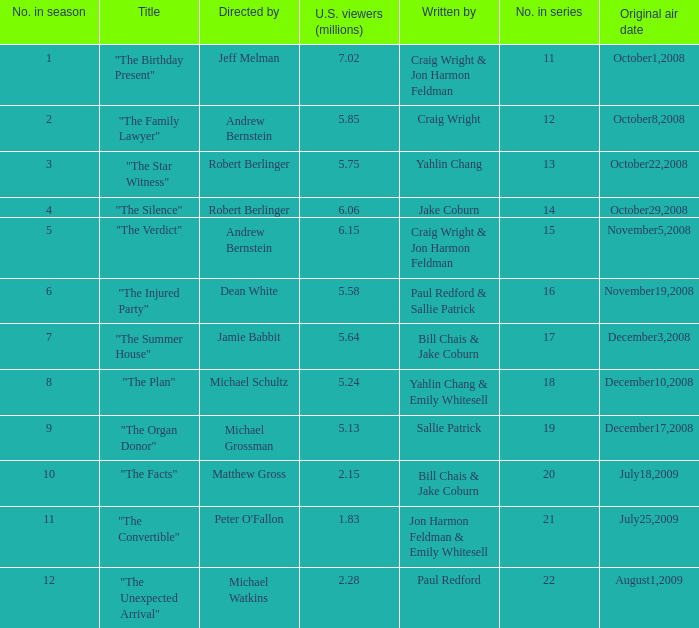Parse the full table. {'header': ['No. in season', 'Title', 'Directed by', 'U.S. viewers (millions)', 'Written by', 'No. in series', 'Original air date'], 'rows': [['1', '"The Birthday Present"', 'Jeff Melman', '7.02', 'Craig Wright & Jon Harmon Feldman', '11', 'October1,2008'], ['2', '"The Family Lawyer"', 'Andrew Bernstein', '5.85', 'Craig Wright', '12', 'October8,2008'], ['3', '"The Star Witness"', 'Robert Berlinger', '5.75', 'Yahlin Chang', '13', 'October22,2008'], ['4', '"The Silence"', 'Robert Berlinger', '6.06', 'Jake Coburn', '14', 'October29,2008'], ['5', '"The Verdict"', 'Andrew Bernstein', '6.15', 'Craig Wright & Jon Harmon Feldman', '15', 'November5,2008'], ['6', '"The Injured Party"', 'Dean White', '5.58', 'Paul Redford & Sallie Patrick', '16', 'November19,2008'], ['7', '"The Summer House"', 'Jamie Babbit', '5.64', 'Bill Chais & Jake Coburn', '17', 'December3,2008'], ['8', '"The Plan"', 'Michael Schultz', '5.24', 'Yahlin Chang & Emily Whitesell', '18', 'December10,2008'], ['9', '"The Organ Donor"', 'Michael Grossman', '5.13', 'Sallie Patrick', '19', 'December17,2008'], ['10', '"The Facts"', 'Matthew Gross', '2.15', 'Bill Chais & Jake Coburn', '20', 'July18,2009'], ['11', '"The Convertible"', "Peter O'Fallon", '1.83', 'Jon Harmon Feldman & Emily Whitesell', '21', 'July25,2009'], ['12', '"The Unexpected Arrival"', 'Michael Watkins', '2.28', 'Paul Redford', '22', 'August1,2009']]} Who wrote the episode that received 1.83 million U.S. viewers? Jon Harmon Feldman & Emily Whitesell. 